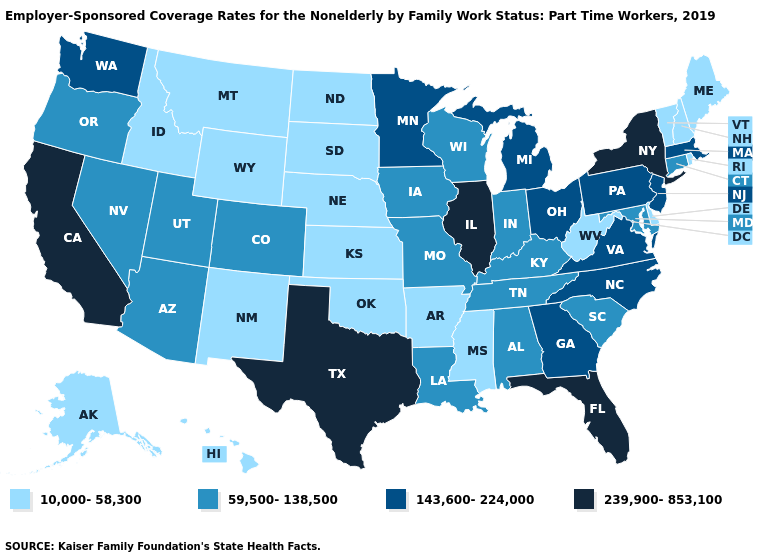Does Delaware have the lowest value in the South?
Write a very short answer. Yes. Does Kansas have the lowest value in the USA?
Be succinct. Yes. Name the states that have a value in the range 239,900-853,100?
Short answer required. California, Florida, Illinois, New York, Texas. What is the value of Pennsylvania?
Quick response, please. 143,600-224,000. What is the lowest value in the USA?
Be succinct. 10,000-58,300. Does Indiana have the lowest value in the USA?
Answer briefly. No. Is the legend a continuous bar?
Write a very short answer. No. What is the lowest value in states that border Washington?
Answer briefly. 10,000-58,300. What is the value of New York?
Concise answer only. 239,900-853,100. Does the map have missing data?
Give a very brief answer. No. What is the value of Maine?
Write a very short answer. 10,000-58,300. Among the states that border Pennsylvania , does New Jersey have the lowest value?
Short answer required. No. Name the states that have a value in the range 143,600-224,000?
Write a very short answer. Georgia, Massachusetts, Michigan, Minnesota, New Jersey, North Carolina, Ohio, Pennsylvania, Virginia, Washington. Name the states that have a value in the range 239,900-853,100?
Concise answer only. California, Florida, Illinois, New York, Texas. Name the states that have a value in the range 239,900-853,100?
Be succinct. California, Florida, Illinois, New York, Texas. 